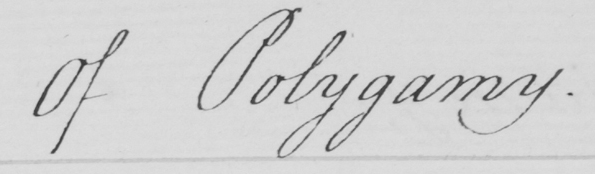What text is written in this handwritten line? Of Polygamy . 